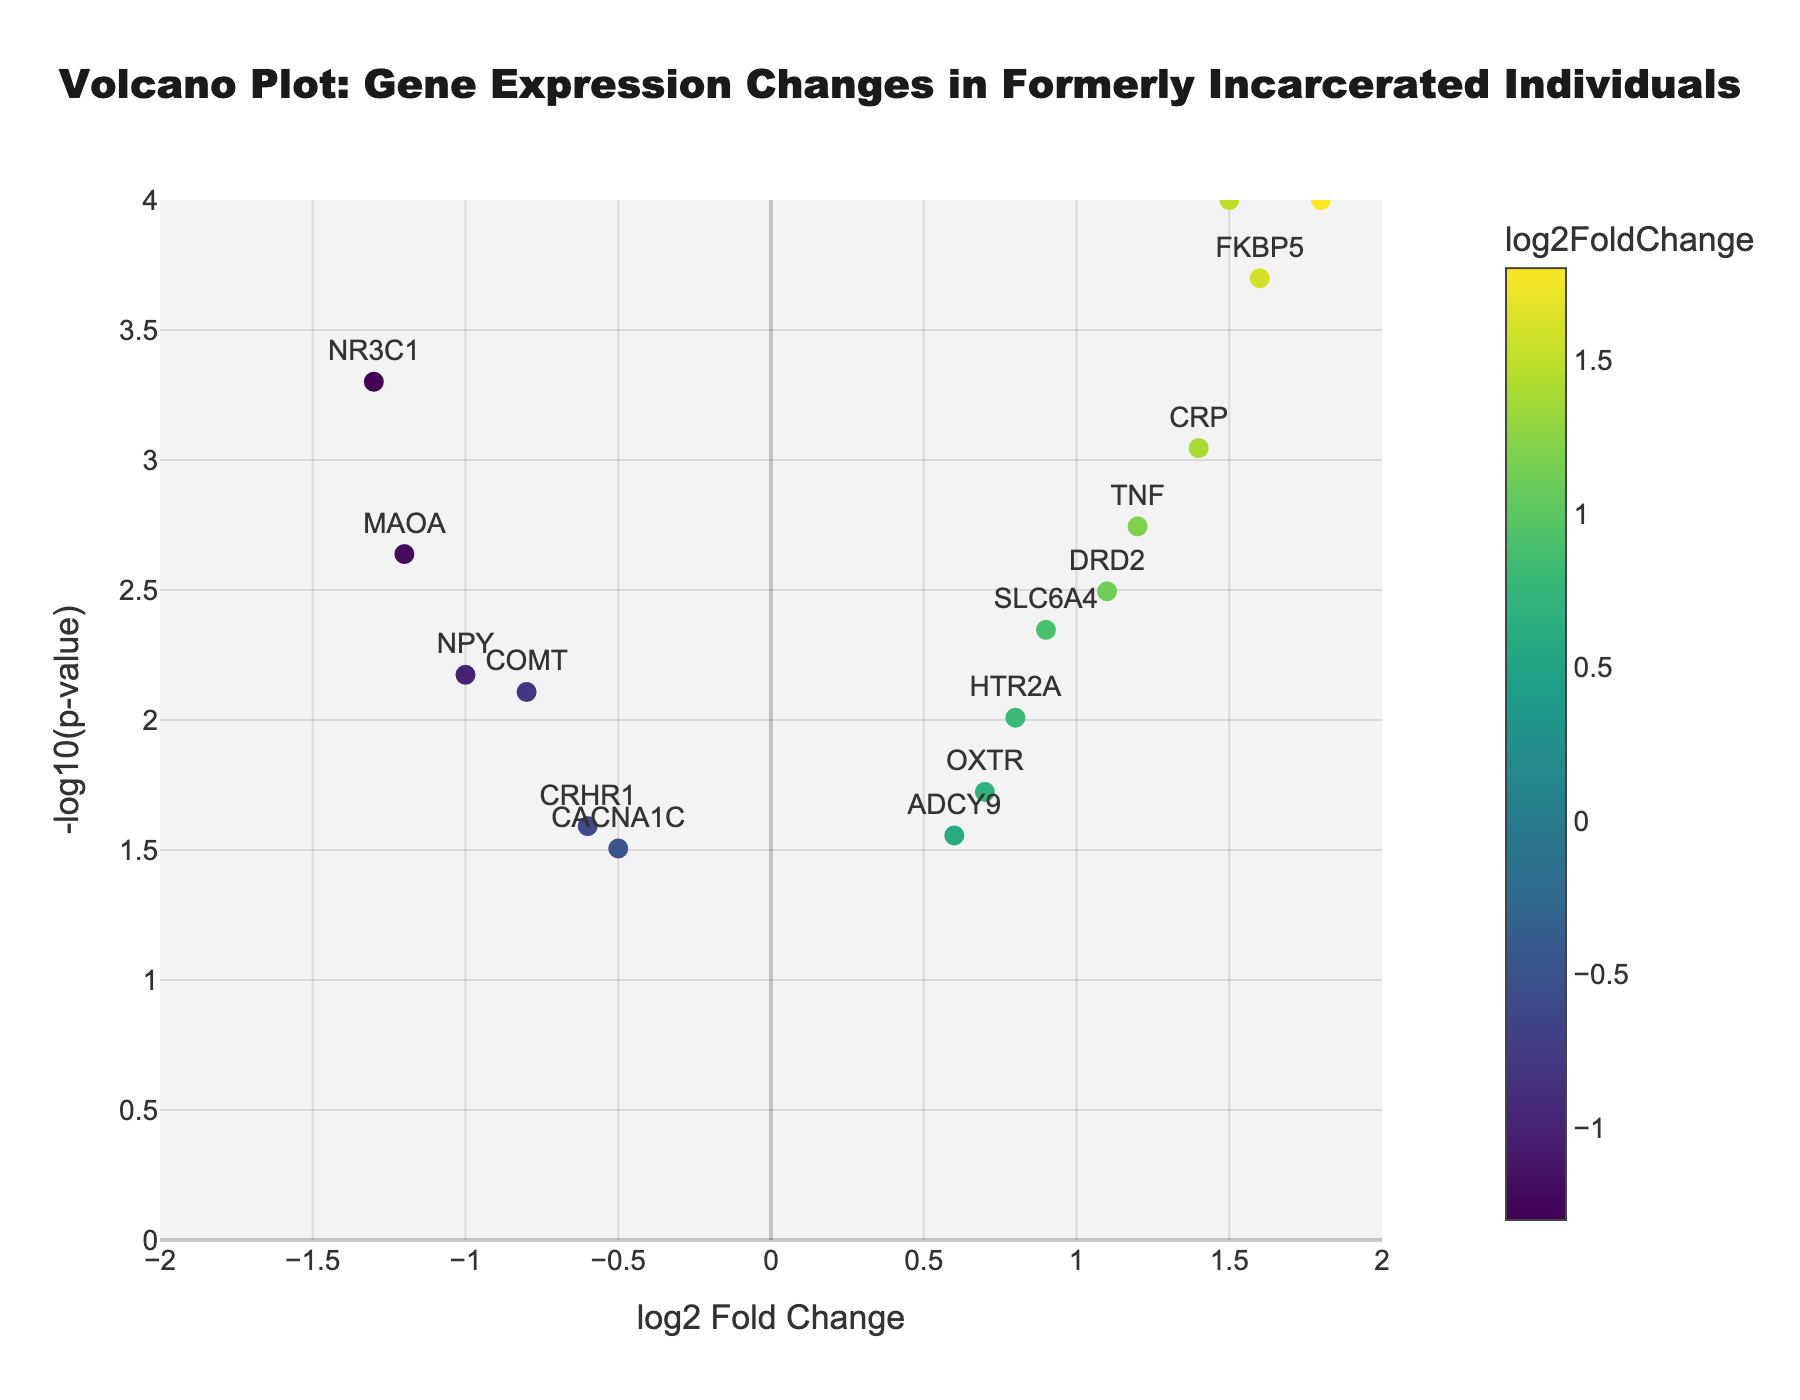How many genes have a log2 fold change greater than 1? To find out how many genes have a log2 fold change greater than 1, observe the points on the x-axis of the plot. Count the number of points right to the 1 mark on the x-axis.
Answer: 4 What is the title of the figure? The title of the figure is typically displayed prominently at the top of the plot.
Answer: "Volcano Plot: Gene Expression Changes in Formerly Incarcerated Individuals" Which gene has the highest log2 fold change and what is its value? To determine which gene has the highest log2 fold change, look for the point farthest to the right on the x-axis and check the label next to it.
Answer: IL6, 1.8 How many genes have a p-value < 0.005? To find the number of genes with p-values < 0.005, locate points above the -log10(p-value) threshold of 2.3 (since -log10(0.005) ≈ 2.3) and count these points.
Answer: 9 Which gene appears closest to the origin of the plot? The point closest to the origin (0,0) on the plot is the one with a log2 fold change and a -log10(p-value) closest to 0.
Answer: CACNA1C Which gene is the most statistically significant, and what is its -log10(p-value)? The most statistically significant gene will be the one furthest up on the y-axis with the highest -log10(p-value). Locate this point and check the label and y-value.
Answer: BDNF, 4.0 What is the range of the x-axis? The range of the x-axis can be determined by looking at the farthest left and right tick marks.
Answer: [-2, 2] How many genes are downregulated (log2 fold change < 0)? To determine the number of downregulated genes, count the points on the left side of the y-axis (log2 fold change < 0).
Answer: 6 Compare the statistical significance of the genes BDNF and DRD2. Which is more significant, and by how much? First, find the -log10(p-value) for both BDNF and DRD2 (BDNF: 4.0, DRD2: 2.5). BDNF is more significant. The difference in their -log10(p-value) is 4.0 - 2.5 = 1.5.
Answer: BDNF, by 1.5 What color scale is used to represent the log2 fold changes, and how does it affect interpretation? The color scale used is 'Viridis'. Colors indicate the magnitude of log2 fold changes, with generally darker colors indicating higher expressions based on the Viridis scale.
Answer: Viridis 